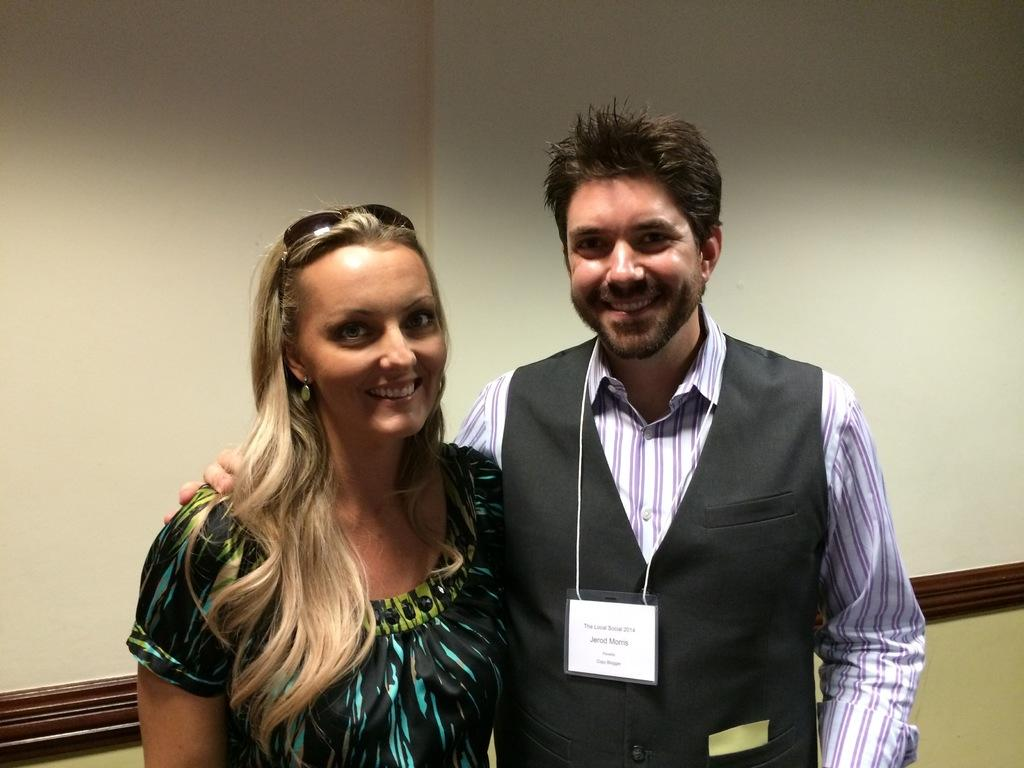How many people are in the image? There are two persons standing in the image. What is the surface they are standing on? The persons are standing on the floor. What can be seen in the background of the image? There is a wall visible in the background of the image. Where might this image have been taken? The image may have been taken in a hall. What type of wool is being used for the treatment on the page in the image? There is no wool, treatment, or page present in the image. 